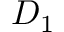<formula> <loc_0><loc_0><loc_500><loc_500>D _ { 1 }</formula> 